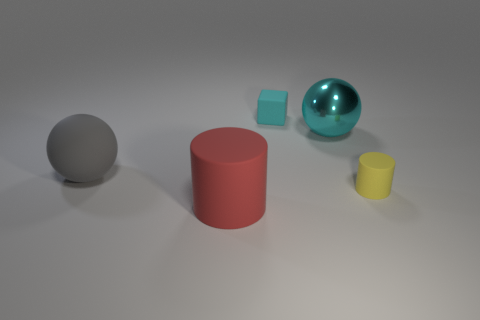Add 5 purple shiny cylinders. How many objects exist? 10 Subtract all yellow cylinders. How many cylinders are left? 1 Subtract all spheres. How many objects are left? 3 Subtract all green cubes. Subtract all gray spheres. How many cubes are left? 1 Subtract all gray matte spheres. Subtract all tiny matte cylinders. How many objects are left? 3 Add 3 large spheres. How many large spheres are left? 5 Add 3 big cyan spheres. How many big cyan spheres exist? 4 Subtract 0 brown cubes. How many objects are left? 5 